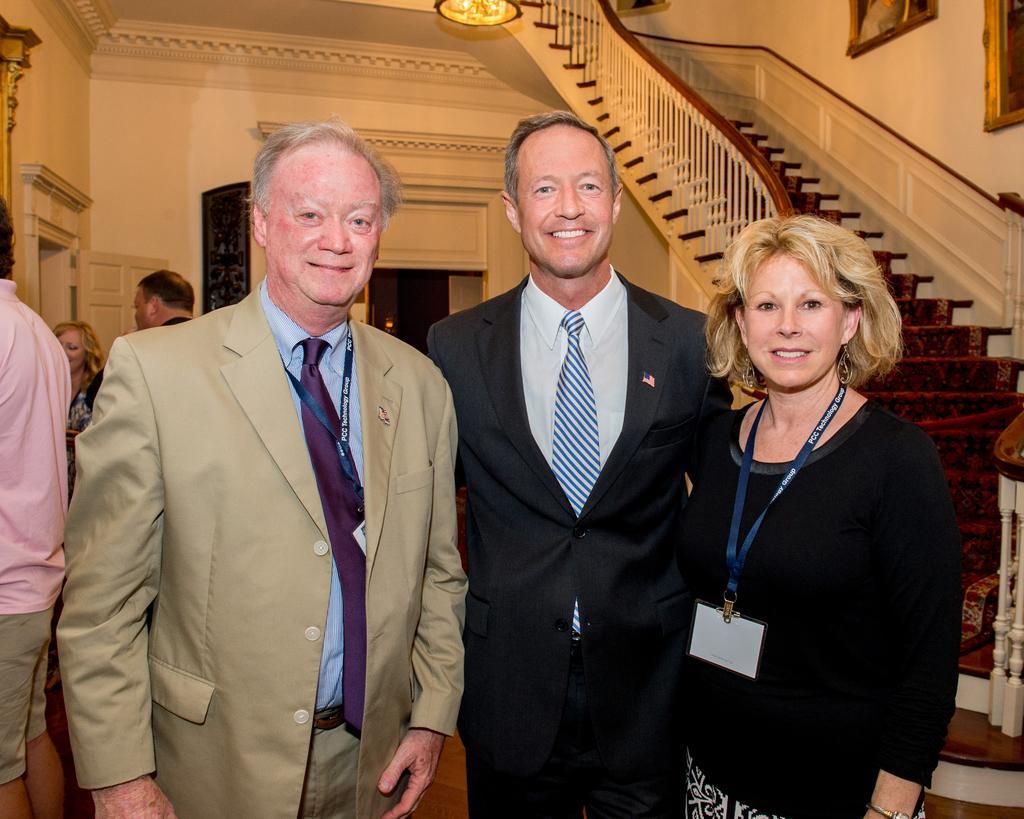In one or two sentences, can you explain what this image depicts? In this image there are few people in the hall, a light hanging from the roof, few frames attached to the wall, stairs and the door. 